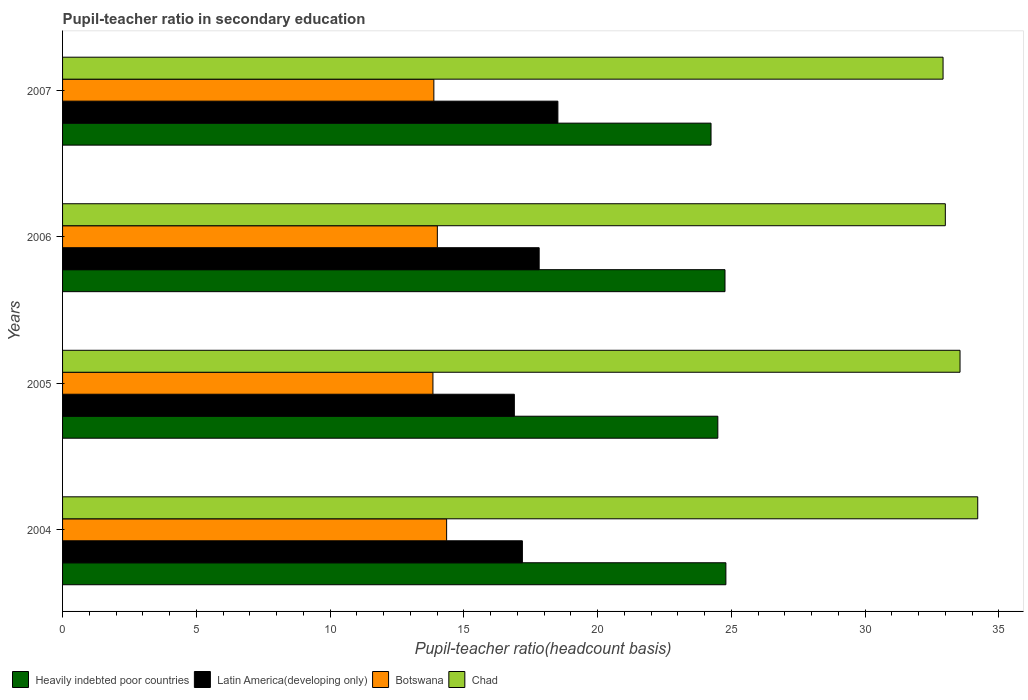Are the number of bars on each tick of the Y-axis equal?
Your response must be concise. Yes. What is the pupil-teacher ratio in secondary education in Botswana in 2005?
Your response must be concise. 13.84. Across all years, what is the maximum pupil-teacher ratio in secondary education in Botswana?
Your response must be concise. 14.36. Across all years, what is the minimum pupil-teacher ratio in secondary education in Latin America(developing only)?
Offer a terse response. 16.89. In which year was the pupil-teacher ratio in secondary education in Heavily indebted poor countries minimum?
Provide a succinct answer. 2007. What is the total pupil-teacher ratio in secondary education in Botswana in the graph?
Provide a short and direct response. 56.09. What is the difference between the pupil-teacher ratio in secondary education in Heavily indebted poor countries in 2004 and that in 2005?
Keep it short and to the point. 0.3. What is the difference between the pupil-teacher ratio in secondary education in Chad in 2006 and the pupil-teacher ratio in secondary education in Botswana in 2005?
Your response must be concise. 19.15. What is the average pupil-teacher ratio in secondary education in Botswana per year?
Ensure brevity in your answer.  14.02. In the year 2006, what is the difference between the pupil-teacher ratio in secondary education in Botswana and pupil-teacher ratio in secondary education in Heavily indebted poor countries?
Offer a very short reply. -10.75. In how many years, is the pupil-teacher ratio in secondary education in Chad greater than 32 ?
Ensure brevity in your answer.  4. What is the ratio of the pupil-teacher ratio in secondary education in Botswana in 2006 to that in 2007?
Provide a succinct answer. 1.01. Is the difference between the pupil-teacher ratio in secondary education in Botswana in 2004 and 2005 greater than the difference between the pupil-teacher ratio in secondary education in Heavily indebted poor countries in 2004 and 2005?
Ensure brevity in your answer.  Yes. What is the difference between the highest and the second highest pupil-teacher ratio in secondary education in Heavily indebted poor countries?
Provide a succinct answer. 0.03. What is the difference between the highest and the lowest pupil-teacher ratio in secondary education in Heavily indebted poor countries?
Give a very brief answer. 0.56. Is the sum of the pupil-teacher ratio in secondary education in Chad in 2006 and 2007 greater than the maximum pupil-teacher ratio in secondary education in Latin America(developing only) across all years?
Provide a short and direct response. Yes. Is it the case that in every year, the sum of the pupil-teacher ratio in secondary education in Heavily indebted poor countries and pupil-teacher ratio in secondary education in Latin America(developing only) is greater than the sum of pupil-teacher ratio in secondary education in Botswana and pupil-teacher ratio in secondary education in Chad?
Keep it short and to the point. No. What does the 2nd bar from the top in 2006 represents?
Provide a succinct answer. Botswana. What does the 2nd bar from the bottom in 2004 represents?
Make the answer very short. Latin America(developing only). Is it the case that in every year, the sum of the pupil-teacher ratio in secondary education in Botswana and pupil-teacher ratio in secondary education in Heavily indebted poor countries is greater than the pupil-teacher ratio in secondary education in Chad?
Your answer should be very brief. Yes. Where does the legend appear in the graph?
Provide a short and direct response. Bottom left. How many legend labels are there?
Give a very brief answer. 4. What is the title of the graph?
Provide a short and direct response. Pupil-teacher ratio in secondary education. Does "High income: nonOECD" appear as one of the legend labels in the graph?
Offer a terse response. No. What is the label or title of the X-axis?
Your answer should be very brief. Pupil-teacher ratio(headcount basis). What is the Pupil-teacher ratio(headcount basis) in Heavily indebted poor countries in 2004?
Provide a succinct answer. 24.79. What is the Pupil-teacher ratio(headcount basis) of Latin America(developing only) in 2004?
Keep it short and to the point. 17.19. What is the Pupil-teacher ratio(headcount basis) in Botswana in 2004?
Your answer should be very brief. 14.36. What is the Pupil-teacher ratio(headcount basis) of Chad in 2004?
Make the answer very short. 34.21. What is the Pupil-teacher ratio(headcount basis) in Heavily indebted poor countries in 2005?
Make the answer very short. 24.49. What is the Pupil-teacher ratio(headcount basis) of Latin America(developing only) in 2005?
Your response must be concise. 16.89. What is the Pupil-teacher ratio(headcount basis) in Botswana in 2005?
Provide a succinct answer. 13.84. What is the Pupil-teacher ratio(headcount basis) in Chad in 2005?
Make the answer very short. 33.55. What is the Pupil-teacher ratio(headcount basis) of Heavily indebted poor countries in 2006?
Make the answer very short. 24.76. What is the Pupil-teacher ratio(headcount basis) in Latin America(developing only) in 2006?
Offer a terse response. 17.81. What is the Pupil-teacher ratio(headcount basis) of Botswana in 2006?
Your answer should be very brief. 14.01. What is the Pupil-teacher ratio(headcount basis) of Chad in 2006?
Make the answer very short. 33. What is the Pupil-teacher ratio(headcount basis) of Heavily indebted poor countries in 2007?
Provide a short and direct response. 24.24. What is the Pupil-teacher ratio(headcount basis) in Latin America(developing only) in 2007?
Make the answer very short. 18.51. What is the Pupil-teacher ratio(headcount basis) in Botswana in 2007?
Provide a short and direct response. 13.88. What is the Pupil-teacher ratio(headcount basis) of Chad in 2007?
Keep it short and to the point. 32.91. Across all years, what is the maximum Pupil-teacher ratio(headcount basis) in Heavily indebted poor countries?
Keep it short and to the point. 24.79. Across all years, what is the maximum Pupil-teacher ratio(headcount basis) in Latin America(developing only)?
Your answer should be very brief. 18.51. Across all years, what is the maximum Pupil-teacher ratio(headcount basis) in Botswana?
Keep it short and to the point. 14.36. Across all years, what is the maximum Pupil-teacher ratio(headcount basis) in Chad?
Your answer should be compact. 34.21. Across all years, what is the minimum Pupil-teacher ratio(headcount basis) in Heavily indebted poor countries?
Keep it short and to the point. 24.24. Across all years, what is the minimum Pupil-teacher ratio(headcount basis) in Latin America(developing only)?
Make the answer very short. 16.89. Across all years, what is the minimum Pupil-teacher ratio(headcount basis) of Botswana?
Offer a very short reply. 13.84. Across all years, what is the minimum Pupil-teacher ratio(headcount basis) of Chad?
Provide a succinct answer. 32.91. What is the total Pupil-teacher ratio(headcount basis) of Heavily indebted poor countries in the graph?
Offer a terse response. 98.29. What is the total Pupil-teacher ratio(headcount basis) of Latin America(developing only) in the graph?
Ensure brevity in your answer.  70.4. What is the total Pupil-teacher ratio(headcount basis) in Botswana in the graph?
Give a very brief answer. 56.09. What is the total Pupil-teacher ratio(headcount basis) in Chad in the graph?
Ensure brevity in your answer.  133.66. What is the difference between the Pupil-teacher ratio(headcount basis) in Heavily indebted poor countries in 2004 and that in 2005?
Your answer should be very brief. 0.3. What is the difference between the Pupil-teacher ratio(headcount basis) in Latin America(developing only) in 2004 and that in 2005?
Make the answer very short. 0.3. What is the difference between the Pupil-teacher ratio(headcount basis) in Botswana in 2004 and that in 2005?
Your response must be concise. 0.51. What is the difference between the Pupil-teacher ratio(headcount basis) of Chad in 2004 and that in 2005?
Offer a terse response. 0.66. What is the difference between the Pupil-teacher ratio(headcount basis) in Heavily indebted poor countries in 2004 and that in 2006?
Provide a short and direct response. 0.03. What is the difference between the Pupil-teacher ratio(headcount basis) in Latin America(developing only) in 2004 and that in 2006?
Make the answer very short. -0.63. What is the difference between the Pupil-teacher ratio(headcount basis) of Botswana in 2004 and that in 2006?
Give a very brief answer. 0.35. What is the difference between the Pupil-teacher ratio(headcount basis) of Chad in 2004 and that in 2006?
Offer a terse response. 1.21. What is the difference between the Pupil-teacher ratio(headcount basis) of Heavily indebted poor countries in 2004 and that in 2007?
Give a very brief answer. 0.56. What is the difference between the Pupil-teacher ratio(headcount basis) of Latin America(developing only) in 2004 and that in 2007?
Provide a short and direct response. -1.33. What is the difference between the Pupil-teacher ratio(headcount basis) of Botswana in 2004 and that in 2007?
Your response must be concise. 0.48. What is the difference between the Pupil-teacher ratio(headcount basis) of Chad in 2004 and that in 2007?
Ensure brevity in your answer.  1.3. What is the difference between the Pupil-teacher ratio(headcount basis) of Heavily indebted poor countries in 2005 and that in 2006?
Keep it short and to the point. -0.27. What is the difference between the Pupil-teacher ratio(headcount basis) in Latin America(developing only) in 2005 and that in 2006?
Keep it short and to the point. -0.93. What is the difference between the Pupil-teacher ratio(headcount basis) in Botswana in 2005 and that in 2006?
Give a very brief answer. -0.16. What is the difference between the Pupil-teacher ratio(headcount basis) of Chad in 2005 and that in 2006?
Provide a succinct answer. 0.55. What is the difference between the Pupil-teacher ratio(headcount basis) of Heavily indebted poor countries in 2005 and that in 2007?
Your response must be concise. 0.25. What is the difference between the Pupil-teacher ratio(headcount basis) of Latin America(developing only) in 2005 and that in 2007?
Offer a very short reply. -1.63. What is the difference between the Pupil-teacher ratio(headcount basis) of Botswana in 2005 and that in 2007?
Keep it short and to the point. -0.03. What is the difference between the Pupil-teacher ratio(headcount basis) of Chad in 2005 and that in 2007?
Offer a very short reply. 0.63. What is the difference between the Pupil-teacher ratio(headcount basis) of Heavily indebted poor countries in 2006 and that in 2007?
Offer a terse response. 0.52. What is the difference between the Pupil-teacher ratio(headcount basis) of Latin America(developing only) in 2006 and that in 2007?
Offer a terse response. -0.7. What is the difference between the Pupil-teacher ratio(headcount basis) in Botswana in 2006 and that in 2007?
Offer a very short reply. 0.13. What is the difference between the Pupil-teacher ratio(headcount basis) of Chad in 2006 and that in 2007?
Keep it short and to the point. 0.08. What is the difference between the Pupil-teacher ratio(headcount basis) of Heavily indebted poor countries in 2004 and the Pupil-teacher ratio(headcount basis) of Latin America(developing only) in 2005?
Your answer should be very brief. 7.91. What is the difference between the Pupil-teacher ratio(headcount basis) in Heavily indebted poor countries in 2004 and the Pupil-teacher ratio(headcount basis) in Botswana in 2005?
Provide a succinct answer. 10.95. What is the difference between the Pupil-teacher ratio(headcount basis) of Heavily indebted poor countries in 2004 and the Pupil-teacher ratio(headcount basis) of Chad in 2005?
Your answer should be very brief. -8.75. What is the difference between the Pupil-teacher ratio(headcount basis) of Latin America(developing only) in 2004 and the Pupil-teacher ratio(headcount basis) of Botswana in 2005?
Your answer should be very brief. 3.34. What is the difference between the Pupil-teacher ratio(headcount basis) of Latin America(developing only) in 2004 and the Pupil-teacher ratio(headcount basis) of Chad in 2005?
Offer a terse response. -16.36. What is the difference between the Pupil-teacher ratio(headcount basis) of Botswana in 2004 and the Pupil-teacher ratio(headcount basis) of Chad in 2005?
Keep it short and to the point. -19.19. What is the difference between the Pupil-teacher ratio(headcount basis) in Heavily indebted poor countries in 2004 and the Pupil-teacher ratio(headcount basis) in Latin America(developing only) in 2006?
Your answer should be compact. 6.98. What is the difference between the Pupil-teacher ratio(headcount basis) of Heavily indebted poor countries in 2004 and the Pupil-teacher ratio(headcount basis) of Botswana in 2006?
Your answer should be compact. 10.79. What is the difference between the Pupil-teacher ratio(headcount basis) of Heavily indebted poor countries in 2004 and the Pupil-teacher ratio(headcount basis) of Chad in 2006?
Provide a short and direct response. -8.2. What is the difference between the Pupil-teacher ratio(headcount basis) in Latin America(developing only) in 2004 and the Pupil-teacher ratio(headcount basis) in Botswana in 2006?
Keep it short and to the point. 3.18. What is the difference between the Pupil-teacher ratio(headcount basis) in Latin America(developing only) in 2004 and the Pupil-teacher ratio(headcount basis) in Chad in 2006?
Offer a terse response. -15.81. What is the difference between the Pupil-teacher ratio(headcount basis) of Botswana in 2004 and the Pupil-teacher ratio(headcount basis) of Chad in 2006?
Give a very brief answer. -18.64. What is the difference between the Pupil-teacher ratio(headcount basis) of Heavily indebted poor countries in 2004 and the Pupil-teacher ratio(headcount basis) of Latin America(developing only) in 2007?
Make the answer very short. 6.28. What is the difference between the Pupil-teacher ratio(headcount basis) in Heavily indebted poor countries in 2004 and the Pupil-teacher ratio(headcount basis) in Botswana in 2007?
Ensure brevity in your answer.  10.92. What is the difference between the Pupil-teacher ratio(headcount basis) of Heavily indebted poor countries in 2004 and the Pupil-teacher ratio(headcount basis) of Chad in 2007?
Your answer should be compact. -8.12. What is the difference between the Pupil-teacher ratio(headcount basis) of Latin America(developing only) in 2004 and the Pupil-teacher ratio(headcount basis) of Botswana in 2007?
Offer a terse response. 3.31. What is the difference between the Pupil-teacher ratio(headcount basis) in Latin America(developing only) in 2004 and the Pupil-teacher ratio(headcount basis) in Chad in 2007?
Make the answer very short. -15.72. What is the difference between the Pupil-teacher ratio(headcount basis) in Botswana in 2004 and the Pupil-teacher ratio(headcount basis) in Chad in 2007?
Your answer should be very brief. -18.56. What is the difference between the Pupil-teacher ratio(headcount basis) in Heavily indebted poor countries in 2005 and the Pupil-teacher ratio(headcount basis) in Latin America(developing only) in 2006?
Your answer should be compact. 6.68. What is the difference between the Pupil-teacher ratio(headcount basis) of Heavily indebted poor countries in 2005 and the Pupil-teacher ratio(headcount basis) of Botswana in 2006?
Your answer should be very brief. 10.48. What is the difference between the Pupil-teacher ratio(headcount basis) in Heavily indebted poor countries in 2005 and the Pupil-teacher ratio(headcount basis) in Chad in 2006?
Your answer should be compact. -8.5. What is the difference between the Pupil-teacher ratio(headcount basis) of Latin America(developing only) in 2005 and the Pupil-teacher ratio(headcount basis) of Botswana in 2006?
Provide a short and direct response. 2.88. What is the difference between the Pupil-teacher ratio(headcount basis) of Latin America(developing only) in 2005 and the Pupil-teacher ratio(headcount basis) of Chad in 2006?
Provide a succinct answer. -16.11. What is the difference between the Pupil-teacher ratio(headcount basis) in Botswana in 2005 and the Pupil-teacher ratio(headcount basis) in Chad in 2006?
Give a very brief answer. -19.15. What is the difference between the Pupil-teacher ratio(headcount basis) in Heavily indebted poor countries in 2005 and the Pupil-teacher ratio(headcount basis) in Latin America(developing only) in 2007?
Offer a very short reply. 5.98. What is the difference between the Pupil-teacher ratio(headcount basis) in Heavily indebted poor countries in 2005 and the Pupil-teacher ratio(headcount basis) in Botswana in 2007?
Give a very brief answer. 10.61. What is the difference between the Pupil-teacher ratio(headcount basis) in Heavily indebted poor countries in 2005 and the Pupil-teacher ratio(headcount basis) in Chad in 2007?
Your answer should be very brief. -8.42. What is the difference between the Pupil-teacher ratio(headcount basis) in Latin America(developing only) in 2005 and the Pupil-teacher ratio(headcount basis) in Botswana in 2007?
Provide a short and direct response. 3.01. What is the difference between the Pupil-teacher ratio(headcount basis) in Latin America(developing only) in 2005 and the Pupil-teacher ratio(headcount basis) in Chad in 2007?
Provide a short and direct response. -16.02. What is the difference between the Pupil-teacher ratio(headcount basis) in Botswana in 2005 and the Pupil-teacher ratio(headcount basis) in Chad in 2007?
Offer a very short reply. -19.07. What is the difference between the Pupil-teacher ratio(headcount basis) in Heavily indebted poor countries in 2006 and the Pupil-teacher ratio(headcount basis) in Latin America(developing only) in 2007?
Offer a terse response. 6.25. What is the difference between the Pupil-teacher ratio(headcount basis) of Heavily indebted poor countries in 2006 and the Pupil-teacher ratio(headcount basis) of Botswana in 2007?
Give a very brief answer. 10.88. What is the difference between the Pupil-teacher ratio(headcount basis) of Heavily indebted poor countries in 2006 and the Pupil-teacher ratio(headcount basis) of Chad in 2007?
Your response must be concise. -8.15. What is the difference between the Pupil-teacher ratio(headcount basis) of Latin America(developing only) in 2006 and the Pupil-teacher ratio(headcount basis) of Botswana in 2007?
Provide a short and direct response. 3.94. What is the difference between the Pupil-teacher ratio(headcount basis) in Latin America(developing only) in 2006 and the Pupil-teacher ratio(headcount basis) in Chad in 2007?
Provide a succinct answer. -15.1. What is the difference between the Pupil-teacher ratio(headcount basis) in Botswana in 2006 and the Pupil-teacher ratio(headcount basis) in Chad in 2007?
Provide a short and direct response. -18.9. What is the average Pupil-teacher ratio(headcount basis) in Heavily indebted poor countries per year?
Give a very brief answer. 24.57. What is the average Pupil-teacher ratio(headcount basis) of Latin America(developing only) per year?
Provide a short and direct response. 17.6. What is the average Pupil-teacher ratio(headcount basis) in Botswana per year?
Keep it short and to the point. 14.02. What is the average Pupil-teacher ratio(headcount basis) in Chad per year?
Ensure brevity in your answer.  33.42. In the year 2004, what is the difference between the Pupil-teacher ratio(headcount basis) in Heavily indebted poor countries and Pupil-teacher ratio(headcount basis) in Latin America(developing only)?
Offer a very short reply. 7.61. In the year 2004, what is the difference between the Pupil-teacher ratio(headcount basis) in Heavily indebted poor countries and Pupil-teacher ratio(headcount basis) in Botswana?
Offer a very short reply. 10.44. In the year 2004, what is the difference between the Pupil-teacher ratio(headcount basis) of Heavily indebted poor countries and Pupil-teacher ratio(headcount basis) of Chad?
Offer a terse response. -9.41. In the year 2004, what is the difference between the Pupil-teacher ratio(headcount basis) of Latin America(developing only) and Pupil-teacher ratio(headcount basis) of Botswana?
Your response must be concise. 2.83. In the year 2004, what is the difference between the Pupil-teacher ratio(headcount basis) in Latin America(developing only) and Pupil-teacher ratio(headcount basis) in Chad?
Provide a short and direct response. -17.02. In the year 2004, what is the difference between the Pupil-teacher ratio(headcount basis) of Botswana and Pupil-teacher ratio(headcount basis) of Chad?
Offer a terse response. -19.85. In the year 2005, what is the difference between the Pupil-teacher ratio(headcount basis) of Heavily indebted poor countries and Pupil-teacher ratio(headcount basis) of Latin America(developing only)?
Keep it short and to the point. 7.61. In the year 2005, what is the difference between the Pupil-teacher ratio(headcount basis) of Heavily indebted poor countries and Pupil-teacher ratio(headcount basis) of Botswana?
Give a very brief answer. 10.65. In the year 2005, what is the difference between the Pupil-teacher ratio(headcount basis) in Heavily indebted poor countries and Pupil-teacher ratio(headcount basis) in Chad?
Make the answer very short. -9.05. In the year 2005, what is the difference between the Pupil-teacher ratio(headcount basis) in Latin America(developing only) and Pupil-teacher ratio(headcount basis) in Botswana?
Your response must be concise. 3.04. In the year 2005, what is the difference between the Pupil-teacher ratio(headcount basis) in Latin America(developing only) and Pupil-teacher ratio(headcount basis) in Chad?
Your response must be concise. -16.66. In the year 2005, what is the difference between the Pupil-teacher ratio(headcount basis) in Botswana and Pupil-teacher ratio(headcount basis) in Chad?
Your answer should be very brief. -19.7. In the year 2006, what is the difference between the Pupil-teacher ratio(headcount basis) in Heavily indebted poor countries and Pupil-teacher ratio(headcount basis) in Latin America(developing only)?
Offer a very short reply. 6.95. In the year 2006, what is the difference between the Pupil-teacher ratio(headcount basis) in Heavily indebted poor countries and Pupil-teacher ratio(headcount basis) in Botswana?
Provide a succinct answer. 10.75. In the year 2006, what is the difference between the Pupil-teacher ratio(headcount basis) of Heavily indebted poor countries and Pupil-teacher ratio(headcount basis) of Chad?
Offer a terse response. -8.24. In the year 2006, what is the difference between the Pupil-teacher ratio(headcount basis) of Latin America(developing only) and Pupil-teacher ratio(headcount basis) of Botswana?
Make the answer very short. 3.81. In the year 2006, what is the difference between the Pupil-teacher ratio(headcount basis) in Latin America(developing only) and Pupil-teacher ratio(headcount basis) in Chad?
Ensure brevity in your answer.  -15.18. In the year 2006, what is the difference between the Pupil-teacher ratio(headcount basis) in Botswana and Pupil-teacher ratio(headcount basis) in Chad?
Make the answer very short. -18.99. In the year 2007, what is the difference between the Pupil-teacher ratio(headcount basis) in Heavily indebted poor countries and Pupil-teacher ratio(headcount basis) in Latin America(developing only)?
Your answer should be compact. 5.72. In the year 2007, what is the difference between the Pupil-teacher ratio(headcount basis) in Heavily indebted poor countries and Pupil-teacher ratio(headcount basis) in Botswana?
Keep it short and to the point. 10.36. In the year 2007, what is the difference between the Pupil-teacher ratio(headcount basis) in Heavily indebted poor countries and Pupil-teacher ratio(headcount basis) in Chad?
Give a very brief answer. -8.67. In the year 2007, what is the difference between the Pupil-teacher ratio(headcount basis) of Latin America(developing only) and Pupil-teacher ratio(headcount basis) of Botswana?
Keep it short and to the point. 4.64. In the year 2007, what is the difference between the Pupil-teacher ratio(headcount basis) in Latin America(developing only) and Pupil-teacher ratio(headcount basis) in Chad?
Keep it short and to the point. -14.4. In the year 2007, what is the difference between the Pupil-teacher ratio(headcount basis) of Botswana and Pupil-teacher ratio(headcount basis) of Chad?
Offer a very short reply. -19.03. What is the ratio of the Pupil-teacher ratio(headcount basis) in Heavily indebted poor countries in 2004 to that in 2005?
Give a very brief answer. 1.01. What is the ratio of the Pupil-teacher ratio(headcount basis) in Latin America(developing only) in 2004 to that in 2005?
Offer a terse response. 1.02. What is the ratio of the Pupil-teacher ratio(headcount basis) of Botswana in 2004 to that in 2005?
Your answer should be very brief. 1.04. What is the ratio of the Pupil-teacher ratio(headcount basis) of Chad in 2004 to that in 2005?
Your answer should be very brief. 1.02. What is the ratio of the Pupil-teacher ratio(headcount basis) of Heavily indebted poor countries in 2004 to that in 2006?
Keep it short and to the point. 1. What is the ratio of the Pupil-teacher ratio(headcount basis) of Latin America(developing only) in 2004 to that in 2006?
Your response must be concise. 0.96. What is the ratio of the Pupil-teacher ratio(headcount basis) in Botswana in 2004 to that in 2006?
Give a very brief answer. 1.02. What is the ratio of the Pupil-teacher ratio(headcount basis) of Chad in 2004 to that in 2006?
Give a very brief answer. 1.04. What is the ratio of the Pupil-teacher ratio(headcount basis) of Heavily indebted poor countries in 2004 to that in 2007?
Give a very brief answer. 1.02. What is the ratio of the Pupil-teacher ratio(headcount basis) of Latin America(developing only) in 2004 to that in 2007?
Your response must be concise. 0.93. What is the ratio of the Pupil-teacher ratio(headcount basis) in Botswana in 2004 to that in 2007?
Provide a succinct answer. 1.03. What is the ratio of the Pupil-teacher ratio(headcount basis) of Chad in 2004 to that in 2007?
Offer a very short reply. 1.04. What is the ratio of the Pupil-teacher ratio(headcount basis) in Heavily indebted poor countries in 2005 to that in 2006?
Your answer should be compact. 0.99. What is the ratio of the Pupil-teacher ratio(headcount basis) in Latin America(developing only) in 2005 to that in 2006?
Give a very brief answer. 0.95. What is the ratio of the Pupil-teacher ratio(headcount basis) of Botswana in 2005 to that in 2006?
Your answer should be compact. 0.99. What is the ratio of the Pupil-teacher ratio(headcount basis) of Chad in 2005 to that in 2006?
Make the answer very short. 1.02. What is the ratio of the Pupil-teacher ratio(headcount basis) in Heavily indebted poor countries in 2005 to that in 2007?
Ensure brevity in your answer.  1.01. What is the ratio of the Pupil-teacher ratio(headcount basis) in Latin America(developing only) in 2005 to that in 2007?
Make the answer very short. 0.91. What is the ratio of the Pupil-teacher ratio(headcount basis) of Botswana in 2005 to that in 2007?
Make the answer very short. 1. What is the ratio of the Pupil-teacher ratio(headcount basis) in Chad in 2005 to that in 2007?
Make the answer very short. 1.02. What is the ratio of the Pupil-teacher ratio(headcount basis) in Heavily indebted poor countries in 2006 to that in 2007?
Keep it short and to the point. 1.02. What is the ratio of the Pupil-teacher ratio(headcount basis) in Latin America(developing only) in 2006 to that in 2007?
Ensure brevity in your answer.  0.96. What is the ratio of the Pupil-teacher ratio(headcount basis) in Botswana in 2006 to that in 2007?
Offer a very short reply. 1.01. What is the difference between the highest and the second highest Pupil-teacher ratio(headcount basis) in Latin America(developing only)?
Your answer should be very brief. 0.7. What is the difference between the highest and the second highest Pupil-teacher ratio(headcount basis) of Botswana?
Keep it short and to the point. 0.35. What is the difference between the highest and the second highest Pupil-teacher ratio(headcount basis) in Chad?
Provide a short and direct response. 0.66. What is the difference between the highest and the lowest Pupil-teacher ratio(headcount basis) of Heavily indebted poor countries?
Provide a succinct answer. 0.56. What is the difference between the highest and the lowest Pupil-teacher ratio(headcount basis) of Latin America(developing only)?
Give a very brief answer. 1.63. What is the difference between the highest and the lowest Pupil-teacher ratio(headcount basis) of Botswana?
Give a very brief answer. 0.51. What is the difference between the highest and the lowest Pupil-teacher ratio(headcount basis) of Chad?
Provide a short and direct response. 1.3. 